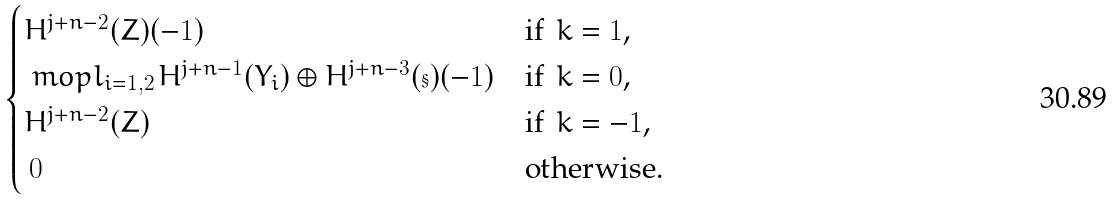Convert formula to latex. <formula><loc_0><loc_0><loc_500><loc_500>\begin{cases} H ^ { j + n - 2 } ( Z ) ( - 1 ) & \text {if $\,k=1$,} \\ \ m o p l _ { i = 1 , 2 \, } H ^ { j + n - 1 } ( Y _ { i } ) \oplus H ^ { j + n - 3 } ( \S ) ( - 1 ) & \text {if $\,k=0$,} \\ H ^ { j + n - 2 } ( Z ) & \text {if $\,k=-1$,} \\ \, 0 & \text {otherwise.} \end{cases}</formula> 